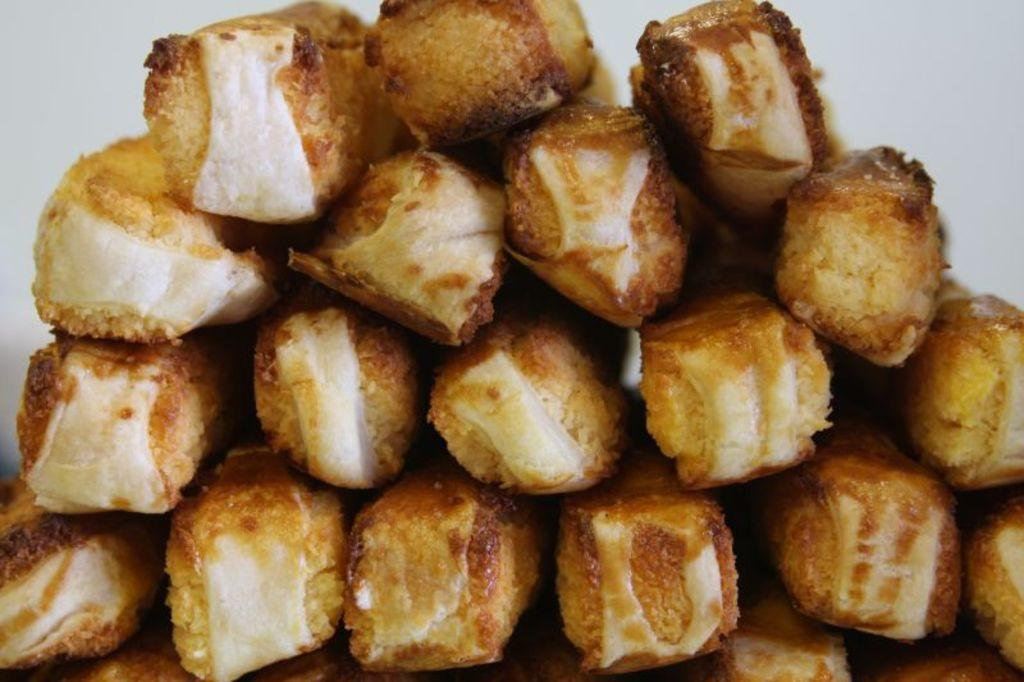What is the main subject of the image? The main subject of the image is food items. What type of cars are parked near the food items in the image? There are no cars present in the image. The main subject of the image is food items, and there is no mention of cars or any other vehicles in the provided facts. 